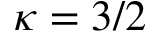Convert formula to latex. <formula><loc_0><loc_0><loc_500><loc_500>\kappa = 3 / 2</formula> 